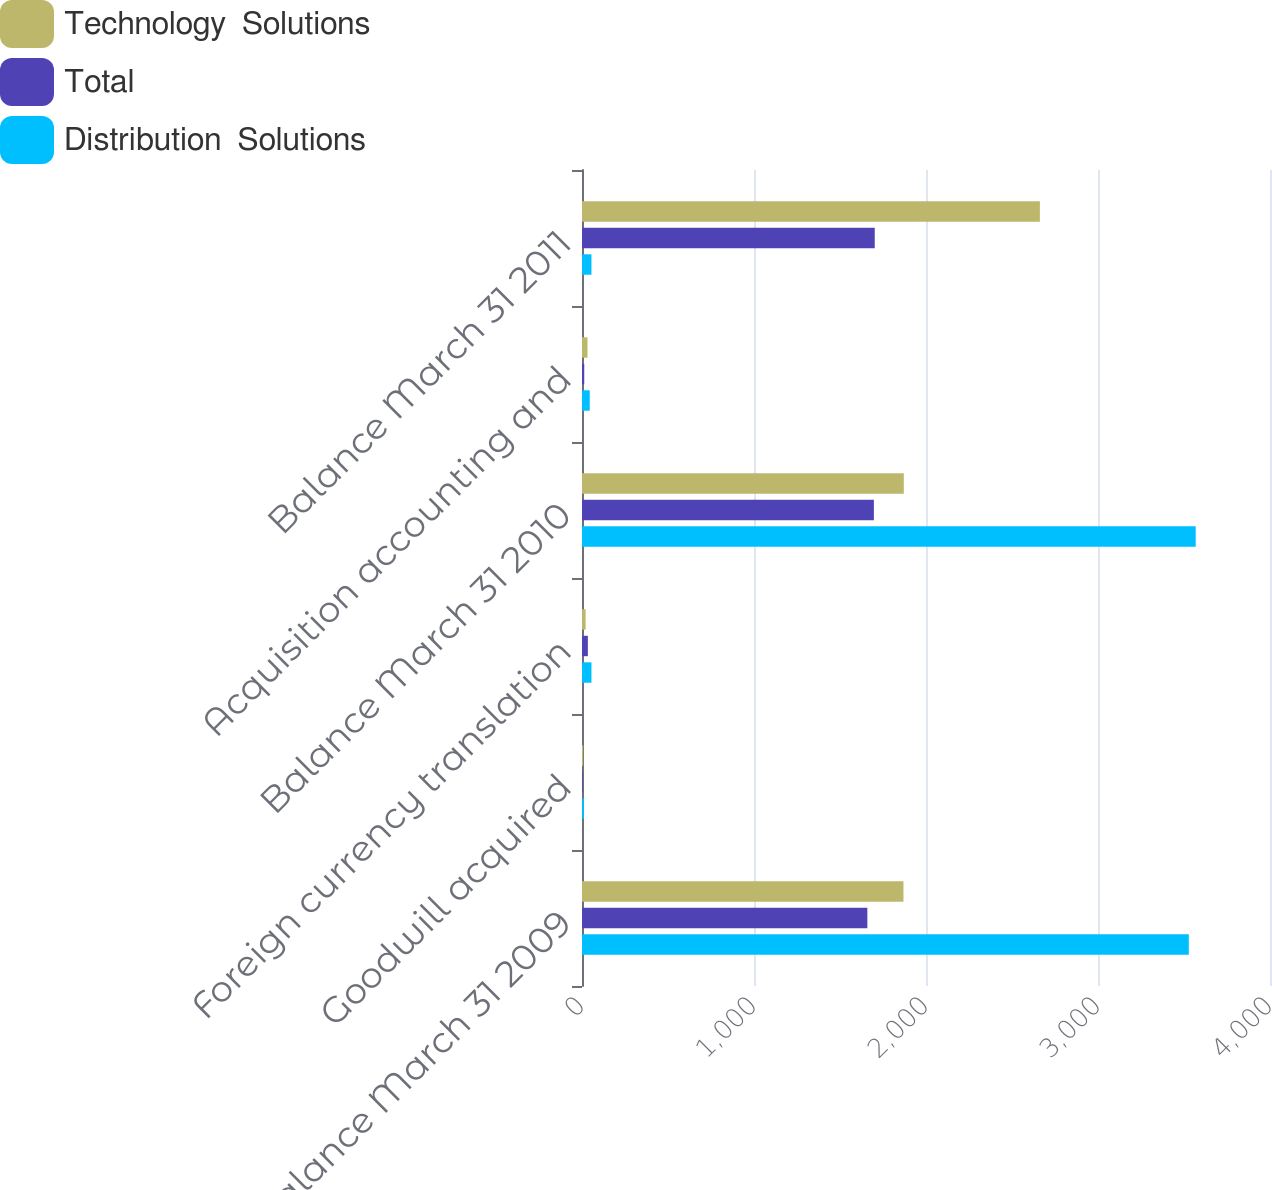Convert chart to OTSL. <chart><loc_0><loc_0><loc_500><loc_500><stacked_bar_chart><ecel><fcel>Balance March 31 2009<fcel>Goodwill acquired<fcel>Foreign currency translation<fcel>Balance March 31 2010<fcel>Acquisition accounting and<fcel>Balance March 31 2011<nl><fcel>Technology  Solutions<fcel>1869<fcel>7<fcel>21<fcel>1871<fcel>32<fcel>2662<nl><fcel>Total<fcel>1659<fcel>4<fcel>34<fcel>1697<fcel>13<fcel>1702<nl><fcel>Distribution  Solutions<fcel>3528<fcel>11<fcel>55<fcel>3568<fcel>45<fcel>55<nl></chart> 